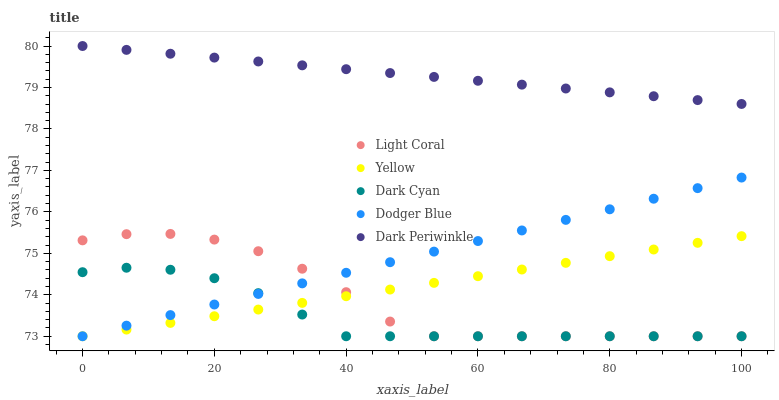Does Dark Cyan have the minimum area under the curve?
Answer yes or no. Yes. Does Dark Periwinkle have the maximum area under the curve?
Answer yes or no. Yes. Does Dodger Blue have the minimum area under the curve?
Answer yes or no. No. Does Dodger Blue have the maximum area under the curve?
Answer yes or no. No. Is Yellow the smoothest?
Answer yes or no. Yes. Is Light Coral the roughest?
Answer yes or no. Yes. Is Dark Cyan the smoothest?
Answer yes or no. No. Is Dark Cyan the roughest?
Answer yes or no. No. Does Light Coral have the lowest value?
Answer yes or no. Yes. Does Dark Periwinkle have the lowest value?
Answer yes or no. No. Does Dark Periwinkle have the highest value?
Answer yes or no. Yes. Does Dodger Blue have the highest value?
Answer yes or no. No. Is Yellow less than Dark Periwinkle?
Answer yes or no. Yes. Is Dark Periwinkle greater than Dark Cyan?
Answer yes or no. Yes. Does Dodger Blue intersect Light Coral?
Answer yes or no. Yes. Is Dodger Blue less than Light Coral?
Answer yes or no. No. Is Dodger Blue greater than Light Coral?
Answer yes or no. No. Does Yellow intersect Dark Periwinkle?
Answer yes or no. No. 